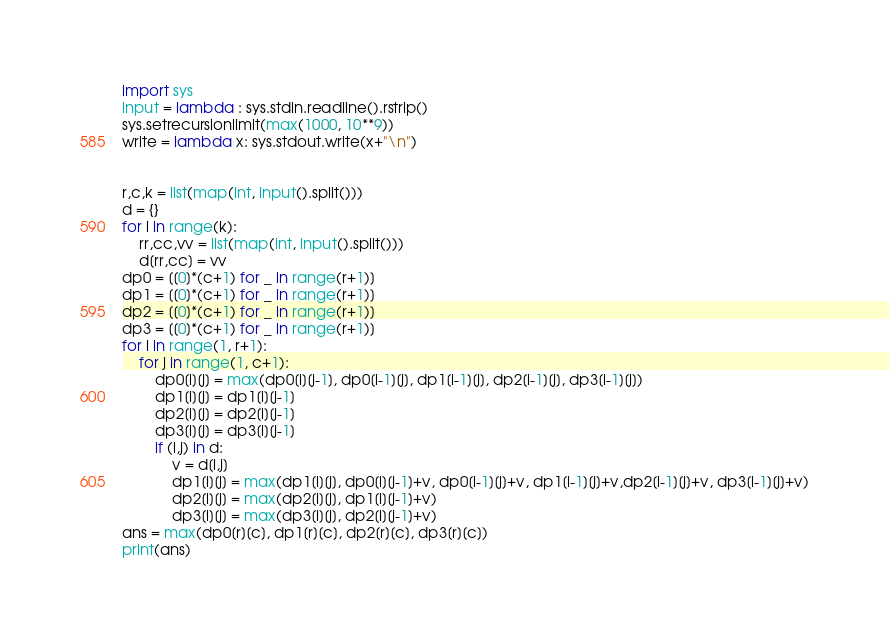Convert code to text. <code><loc_0><loc_0><loc_500><loc_500><_Python_>import sys
input = lambda : sys.stdin.readline().rstrip()
sys.setrecursionlimit(max(1000, 10**9))
write = lambda x: sys.stdout.write(x+"\n")


r,c,k = list(map(int, input().split()))
d = {}
for i in range(k):
    rr,cc,vv = list(map(int, input().split()))
    d[rr,cc] = vv
dp0 = [[0]*(c+1) for _ in range(r+1)]
dp1 = [[0]*(c+1) for _ in range(r+1)]
dp2 = [[0]*(c+1) for _ in range(r+1)]
dp3 = [[0]*(c+1) for _ in range(r+1)]
for i in range(1, r+1):
    for j in range(1, c+1):
        dp0[i][j] = max(dp0[i][j-1], dp0[i-1][j], dp1[i-1][j], dp2[i-1][j], dp3[i-1][j])
        dp1[i][j] = dp1[i][j-1]
        dp2[i][j] = dp2[i][j-1]
        dp3[i][j] = dp3[i][j-1]
        if (i,j) in d:
            v = d[i,j]
            dp1[i][j] = max(dp1[i][j], dp0[i][j-1]+v, dp0[i-1][j]+v, dp1[i-1][j]+v,dp2[i-1][j]+v, dp3[i-1][j]+v)
            dp2[i][j] = max(dp2[i][j], dp1[i][j-1]+v)
            dp3[i][j] = max(dp3[i][j], dp2[i][j-1]+v)
ans = max(dp0[r][c], dp1[r][c], dp2[r][c], dp3[r][c])
print(ans)</code> 